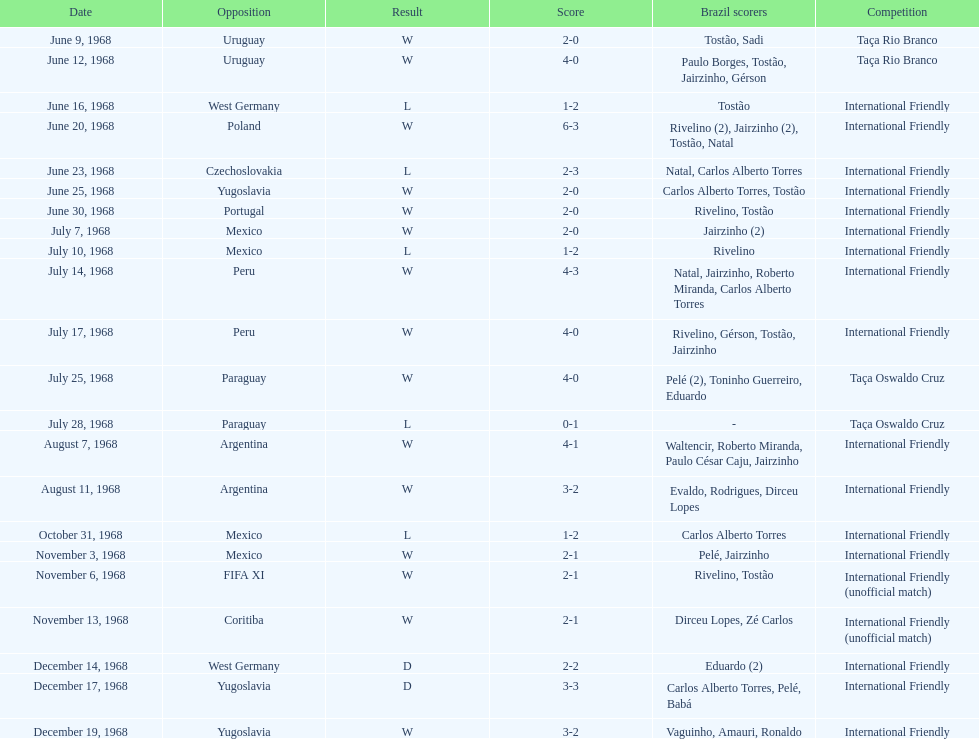How many losses are there? 5. 